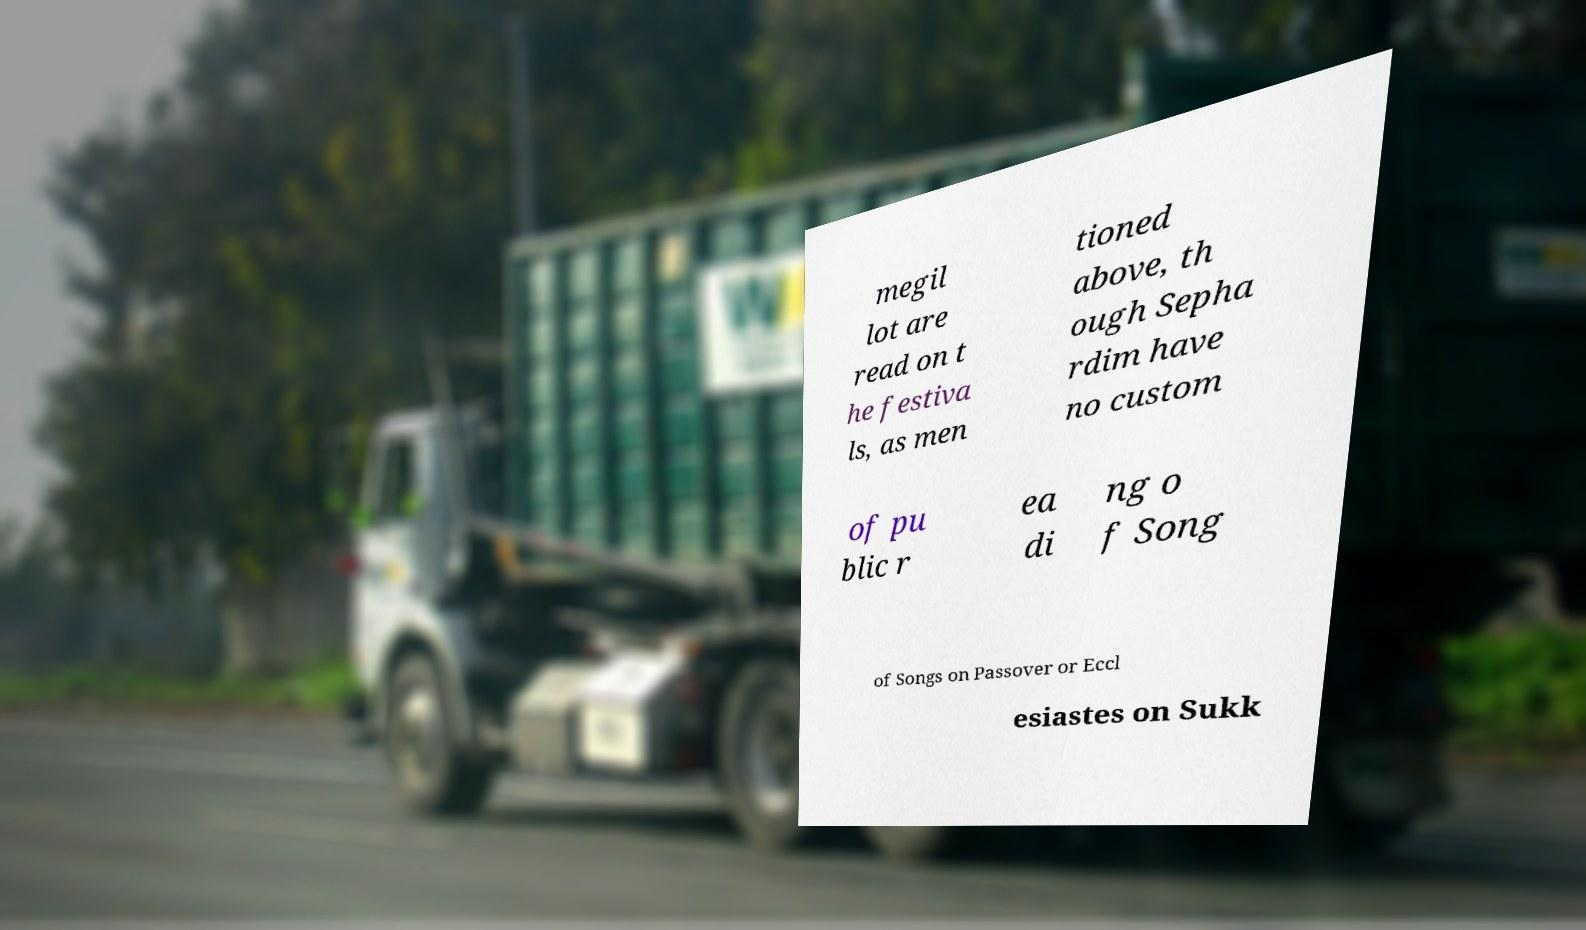Please identify and transcribe the text found in this image. megil lot are read on t he festiva ls, as men tioned above, th ough Sepha rdim have no custom of pu blic r ea di ng o f Song of Songs on Passover or Eccl esiastes on Sukk 